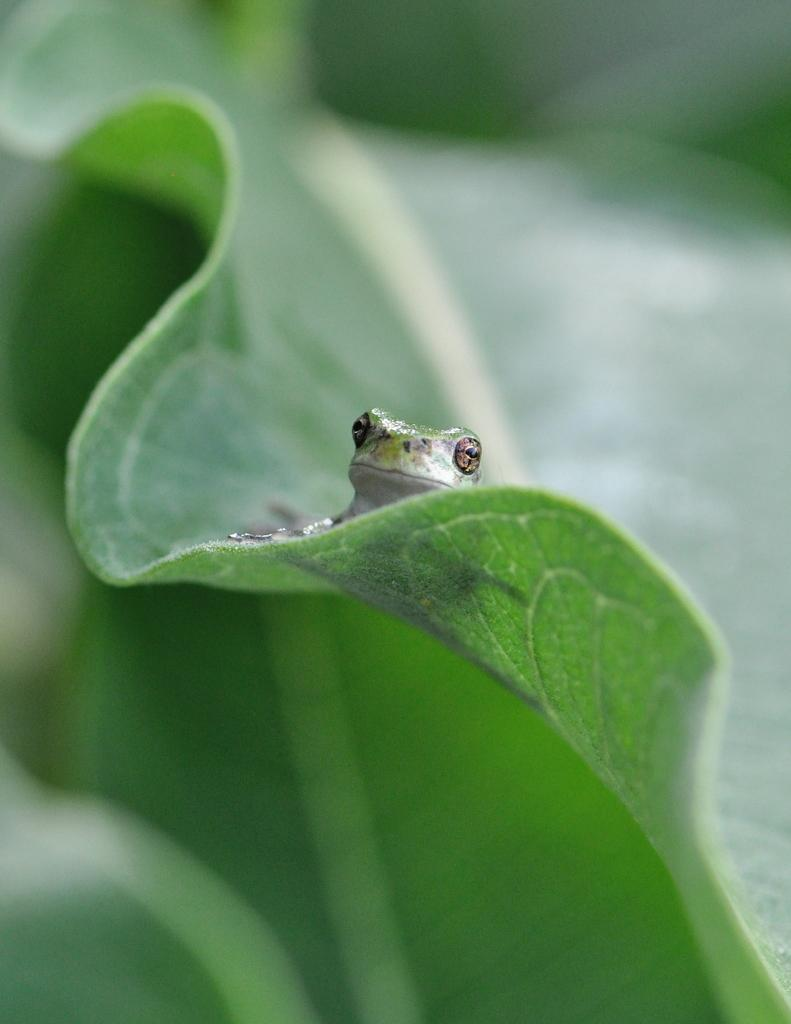What animal is present in the image? There is a frog in the image. What is the frog sitting on? The frog is on green leaves. What type of vegetation can be seen at the bottom of the image? There are leaves visible at the bottom of the image. What is the color of the background in the image? The background of the image is green in color. How would you describe the focus of the image? The image is blurred in the background, suggesting that the frog on the green leaves is the main focus. What type of quilt is being used to cover the frog in the image? There is no quilt present in the image; the frog is sitting on green leaves. How many planes can be seen flying in the background of the image? There are no planes visible in the image; the background is green and blurred. 